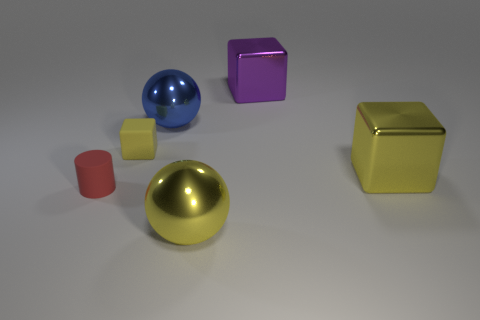Subtract all large metal cubes. How many cubes are left? 1 Subtract all purple cubes. How many cubes are left? 2 Add 3 large yellow cylinders. How many objects exist? 9 Subtract 1 red cylinders. How many objects are left? 5 Subtract all cylinders. How many objects are left? 5 Subtract 2 spheres. How many spheres are left? 0 Subtract all yellow cylinders. Subtract all green blocks. How many cylinders are left? 1 Subtract all gray cylinders. How many blue balls are left? 1 Subtract all tiny red rubber objects. Subtract all big things. How many objects are left? 1 Add 2 yellow metal objects. How many yellow metal objects are left? 4 